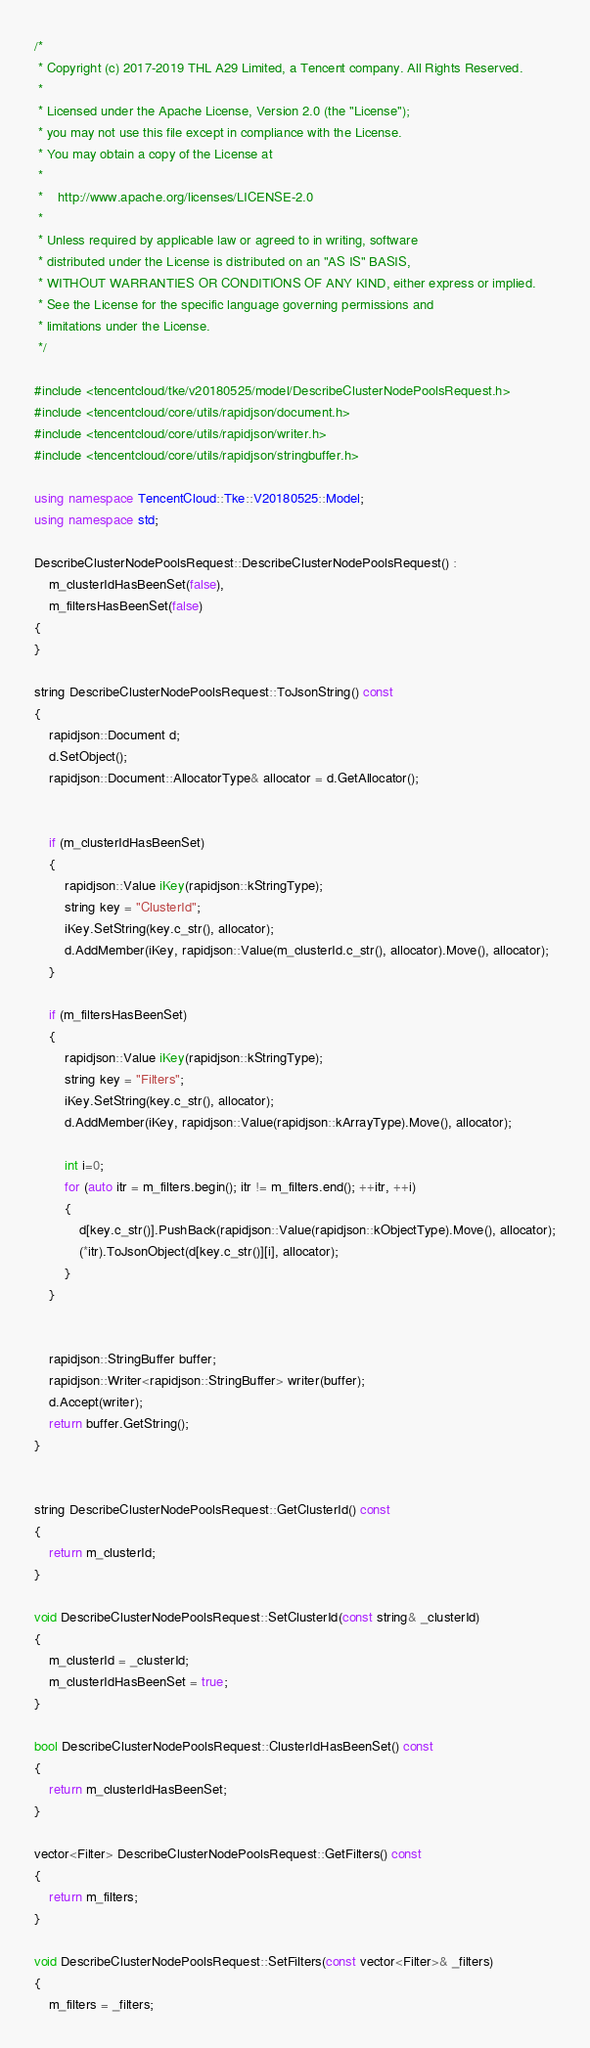Convert code to text. <code><loc_0><loc_0><loc_500><loc_500><_C++_>/*
 * Copyright (c) 2017-2019 THL A29 Limited, a Tencent company. All Rights Reserved.
 *
 * Licensed under the Apache License, Version 2.0 (the "License");
 * you may not use this file except in compliance with the License.
 * You may obtain a copy of the License at
 *
 *    http://www.apache.org/licenses/LICENSE-2.0
 *
 * Unless required by applicable law or agreed to in writing, software
 * distributed under the License is distributed on an "AS IS" BASIS,
 * WITHOUT WARRANTIES OR CONDITIONS OF ANY KIND, either express or implied.
 * See the License for the specific language governing permissions and
 * limitations under the License.
 */

#include <tencentcloud/tke/v20180525/model/DescribeClusterNodePoolsRequest.h>
#include <tencentcloud/core/utils/rapidjson/document.h>
#include <tencentcloud/core/utils/rapidjson/writer.h>
#include <tencentcloud/core/utils/rapidjson/stringbuffer.h>

using namespace TencentCloud::Tke::V20180525::Model;
using namespace std;

DescribeClusterNodePoolsRequest::DescribeClusterNodePoolsRequest() :
    m_clusterIdHasBeenSet(false),
    m_filtersHasBeenSet(false)
{
}

string DescribeClusterNodePoolsRequest::ToJsonString() const
{
    rapidjson::Document d;
    d.SetObject();
    rapidjson::Document::AllocatorType& allocator = d.GetAllocator();


    if (m_clusterIdHasBeenSet)
    {
        rapidjson::Value iKey(rapidjson::kStringType);
        string key = "ClusterId";
        iKey.SetString(key.c_str(), allocator);
        d.AddMember(iKey, rapidjson::Value(m_clusterId.c_str(), allocator).Move(), allocator);
    }

    if (m_filtersHasBeenSet)
    {
        rapidjson::Value iKey(rapidjson::kStringType);
        string key = "Filters";
        iKey.SetString(key.c_str(), allocator);
        d.AddMember(iKey, rapidjson::Value(rapidjson::kArrayType).Move(), allocator);

        int i=0;
        for (auto itr = m_filters.begin(); itr != m_filters.end(); ++itr, ++i)
        {
            d[key.c_str()].PushBack(rapidjson::Value(rapidjson::kObjectType).Move(), allocator);
            (*itr).ToJsonObject(d[key.c_str()][i], allocator);
        }
    }


    rapidjson::StringBuffer buffer;
    rapidjson::Writer<rapidjson::StringBuffer> writer(buffer);
    d.Accept(writer);
    return buffer.GetString();
}


string DescribeClusterNodePoolsRequest::GetClusterId() const
{
    return m_clusterId;
}

void DescribeClusterNodePoolsRequest::SetClusterId(const string& _clusterId)
{
    m_clusterId = _clusterId;
    m_clusterIdHasBeenSet = true;
}

bool DescribeClusterNodePoolsRequest::ClusterIdHasBeenSet() const
{
    return m_clusterIdHasBeenSet;
}

vector<Filter> DescribeClusterNodePoolsRequest::GetFilters() const
{
    return m_filters;
}

void DescribeClusterNodePoolsRequest::SetFilters(const vector<Filter>& _filters)
{
    m_filters = _filters;</code> 